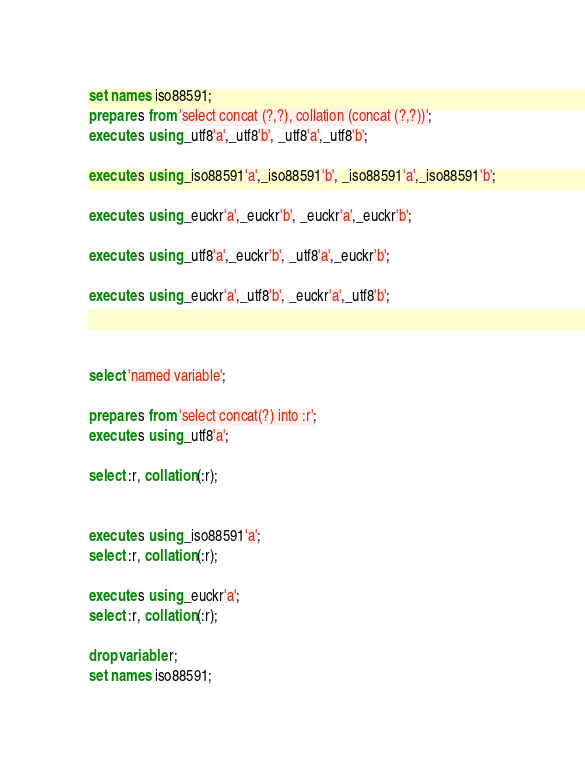<code> <loc_0><loc_0><loc_500><loc_500><_SQL_>set names iso88591;
prepare s from 'select concat (?,?), collation (concat (?,?))';
execute s using _utf8'a',_utf8'b', _utf8'a',_utf8'b';

execute s using _iso88591'a',_iso88591'b', _iso88591'a',_iso88591'b';

execute s using _euckr'a',_euckr'b', _euckr'a',_euckr'b';

execute s using _utf8'a',_euckr'b', _utf8'a',_euckr'b';

execute s using _euckr'a',_utf8'b', _euckr'a',_utf8'b';



select 'named variable';

prepare s from 'select concat(?) into :r';
execute s using _utf8'a';

select :r, collation (:r);


execute s using _iso88591'a';
select :r, collation (:r);

execute s using _euckr'a';
select :r, collation (:r);

drop variable r;
set names iso88591;
</code> 